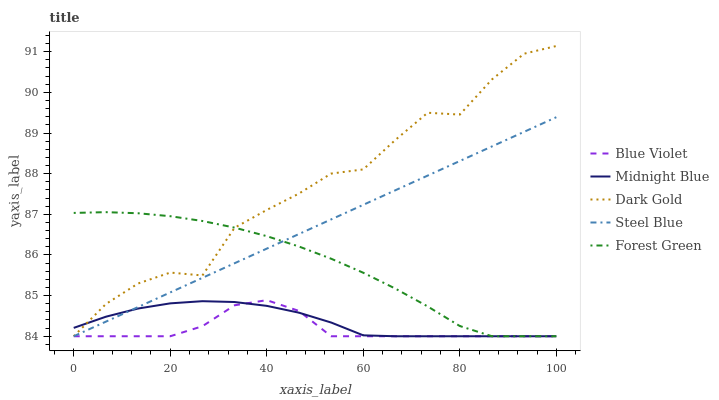Does Blue Violet have the minimum area under the curve?
Answer yes or no. Yes. Does Dark Gold have the maximum area under the curve?
Answer yes or no. Yes. Does Steel Blue have the minimum area under the curve?
Answer yes or no. No. Does Steel Blue have the maximum area under the curve?
Answer yes or no. No. Is Steel Blue the smoothest?
Answer yes or no. Yes. Is Dark Gold the roughest?
Answer yes or no. Yes. Is Midnight Blue the smoothest?
Answer yes or no. No. Is Midnight Blue the roughest?
Answer yes or no. No. Does Forest Green have the lowest value?
Answer yes or no. Yes. Does Dark Gold have the highest value?
Answer yes or no. Yes. Does Steel Blue have the highest value?
Answer yes or no. No. Does Forest Green intersect Blue Violet?
Answer yes or no. Yes. Is Forest Green less than Blue Violet?
Answer yes or no. No. Is Forest Green greater than Blue Violet?
Answer yes or no. No. 